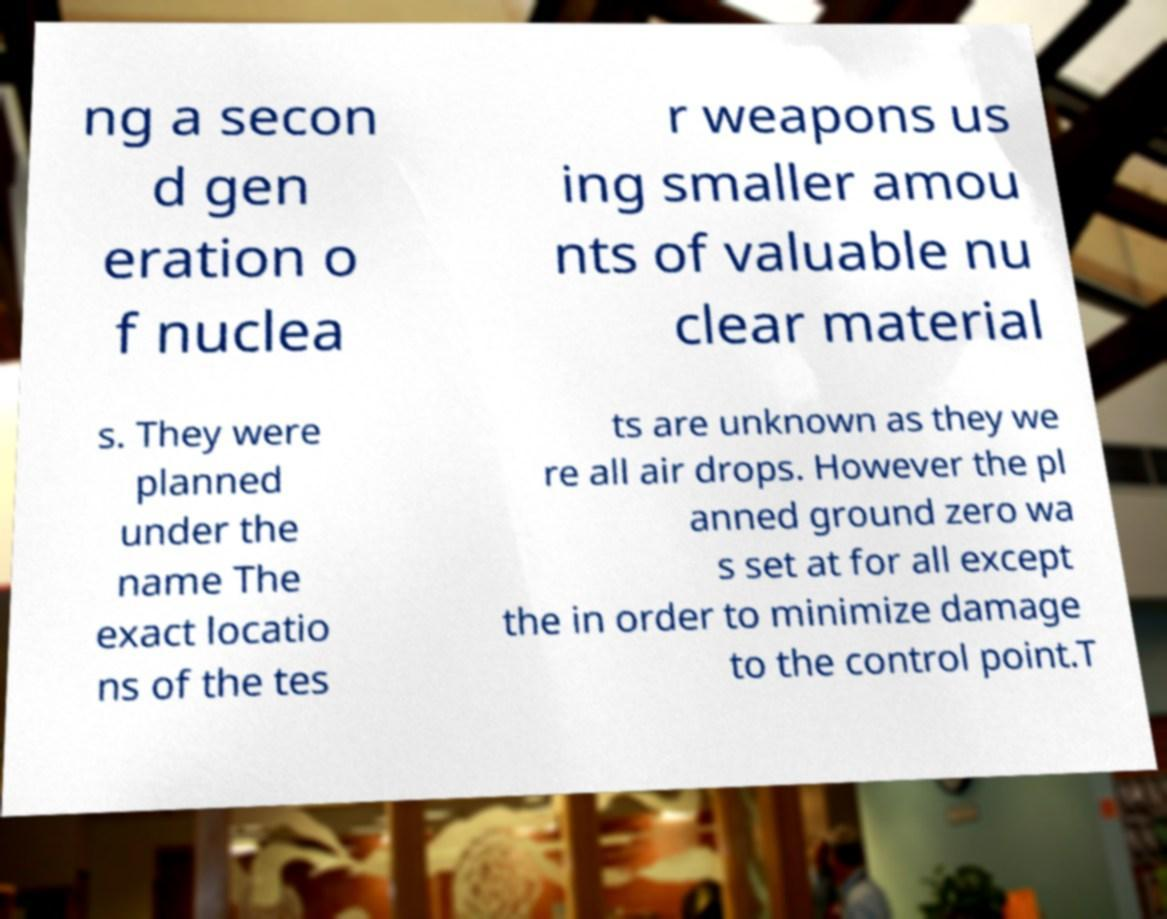I need the written content from this picture converted into text. Can you do that? ng a secon d gen eration o f nuclea r weapons us ing smaller amou nts of valuable nu clear material s. They were planned under the name The exact locatio ns of the tes ts are unknown as they we re all air drops. However the pl anned ground zero wa s set at for all except the in order to minimize damage to the control point.T 